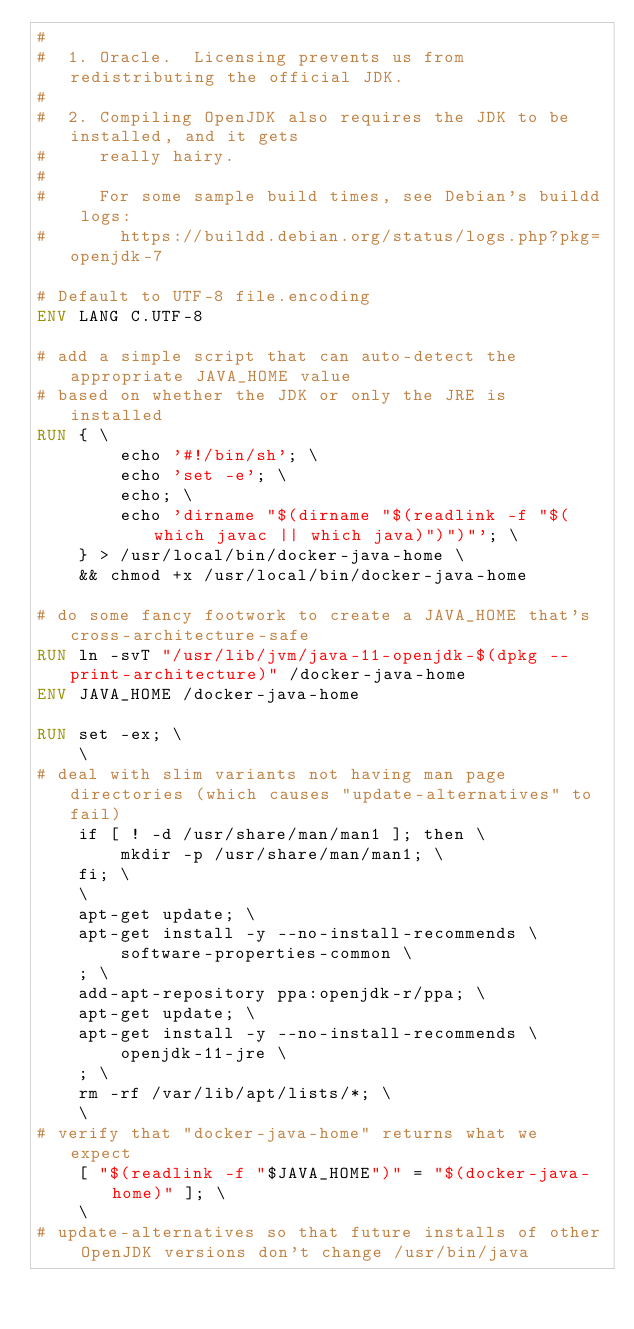<code> <loc_0><loc_0><loc_500><loc_500><_Dockerfile_>#
#  1. Oracle.  Licensing prevents us from redistributing the official JDK.
#
#  2. Compiling OpenJDK also requires the JDK to be installed, and it gets
#     really hairy.
#
#     For some sample build times, see Debian's buildd logs:
#       https://buildd.debian.org/status/logs.php?pkg=openjdk-7

# Default to UTF-8 file.encoding
ENV LANG C.UTF-8

# add a simple script that can auto-detect the appropriate JAVA_HOME value
# based on whether the JDK or only the JRE is installed
RUN { \
		echo '#!/bin/sh'; \
		echo 'set -e'; \
		echo; \
		echo 'dirname "$(dirname "$(readlink -f "$(which javac || which java)")")"'; \
	} > /usr/local/bin/docker-java-home \
	&& chmod +x /usr/local/bin/docker-java-home

# do some fancy footwork to create a JAVA_HOME that's cross-architecture-safe
RUN ln -svT "/usr/lib/jvm/java-11-openjdk-$(dpkg --print-architecture)" /docker-java-home
ENV JAVA_HOME /docker-java-home

RUN set -ex; \
	\
# deal with slim variants not having man page directories (which causes "update-alternatives" to fail)
	if [ ! -d /usr/share/man/man1 ]; then \
		mkdir -p /usr/share/man/man1; \
	fi; \
	\
	apt-get update; \
	apt-get install -y --no-install-recommends \
		software-properties-common \
	; \
	add-apt-repository ppa:openjdk-r/ppa; \
	apt-get update; \
	apt-get install -y --no-install-recommends \
		openjdk-11-jre \
	; \
	rm -rf /var/lib/apt/lists/*; \
	\
# verify that "docker-java-home" returns what we expect
	[ "$(readlink -f "$JAVA_HOME")" = "$(docker-java-home)" ]; \
	\
# update-alternatives so that future installs of other OpenJDK versions don't change /usr/bin/java</code> 